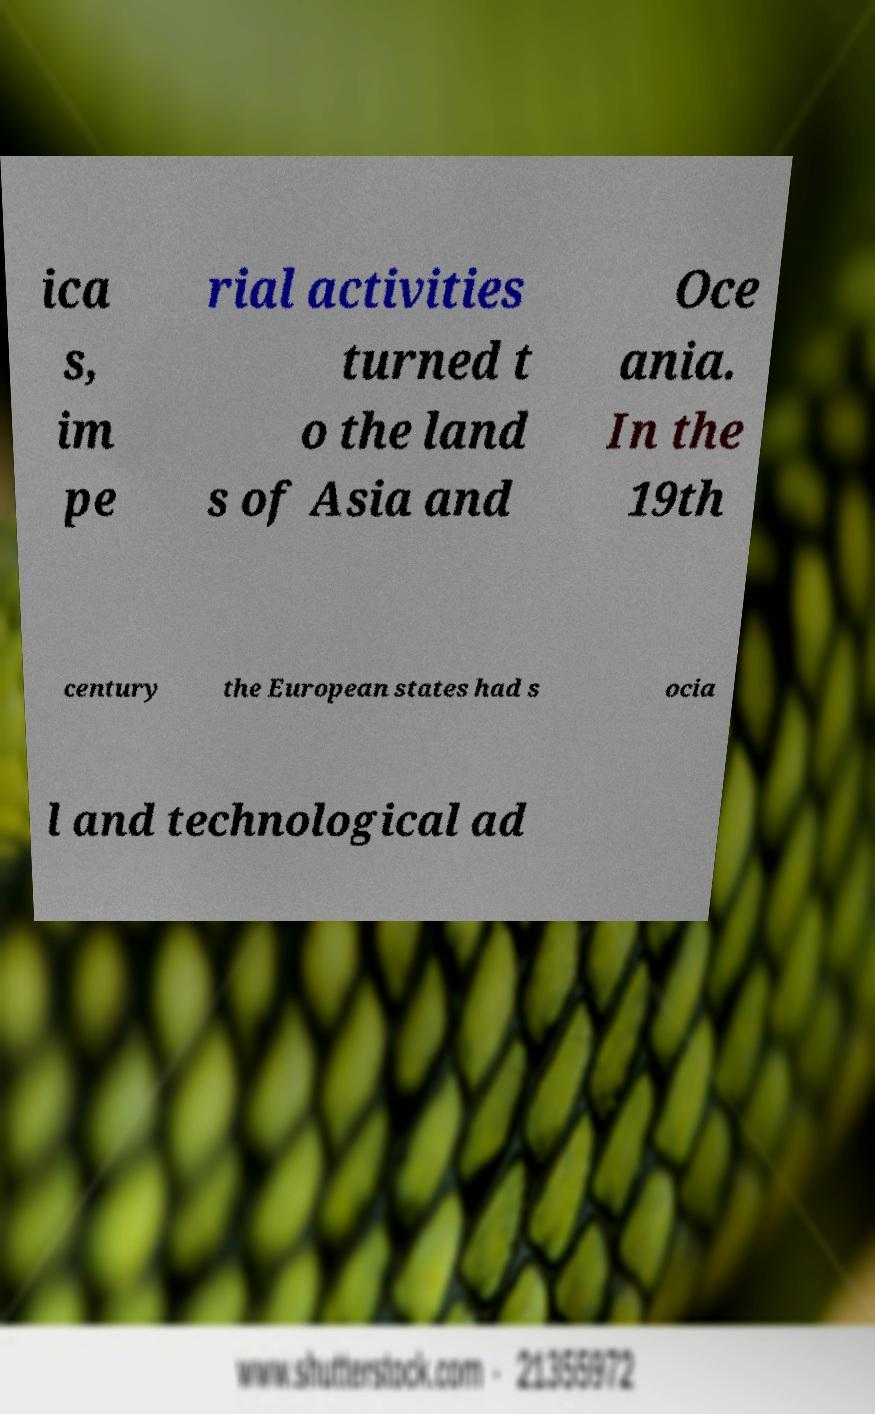Can you accurately transcribe the text from the provided image for me? ica s, im pe rial activities turned t o the land s of Asia and Oce ania. In the 19th century the European states had s ocia l and technological ad 